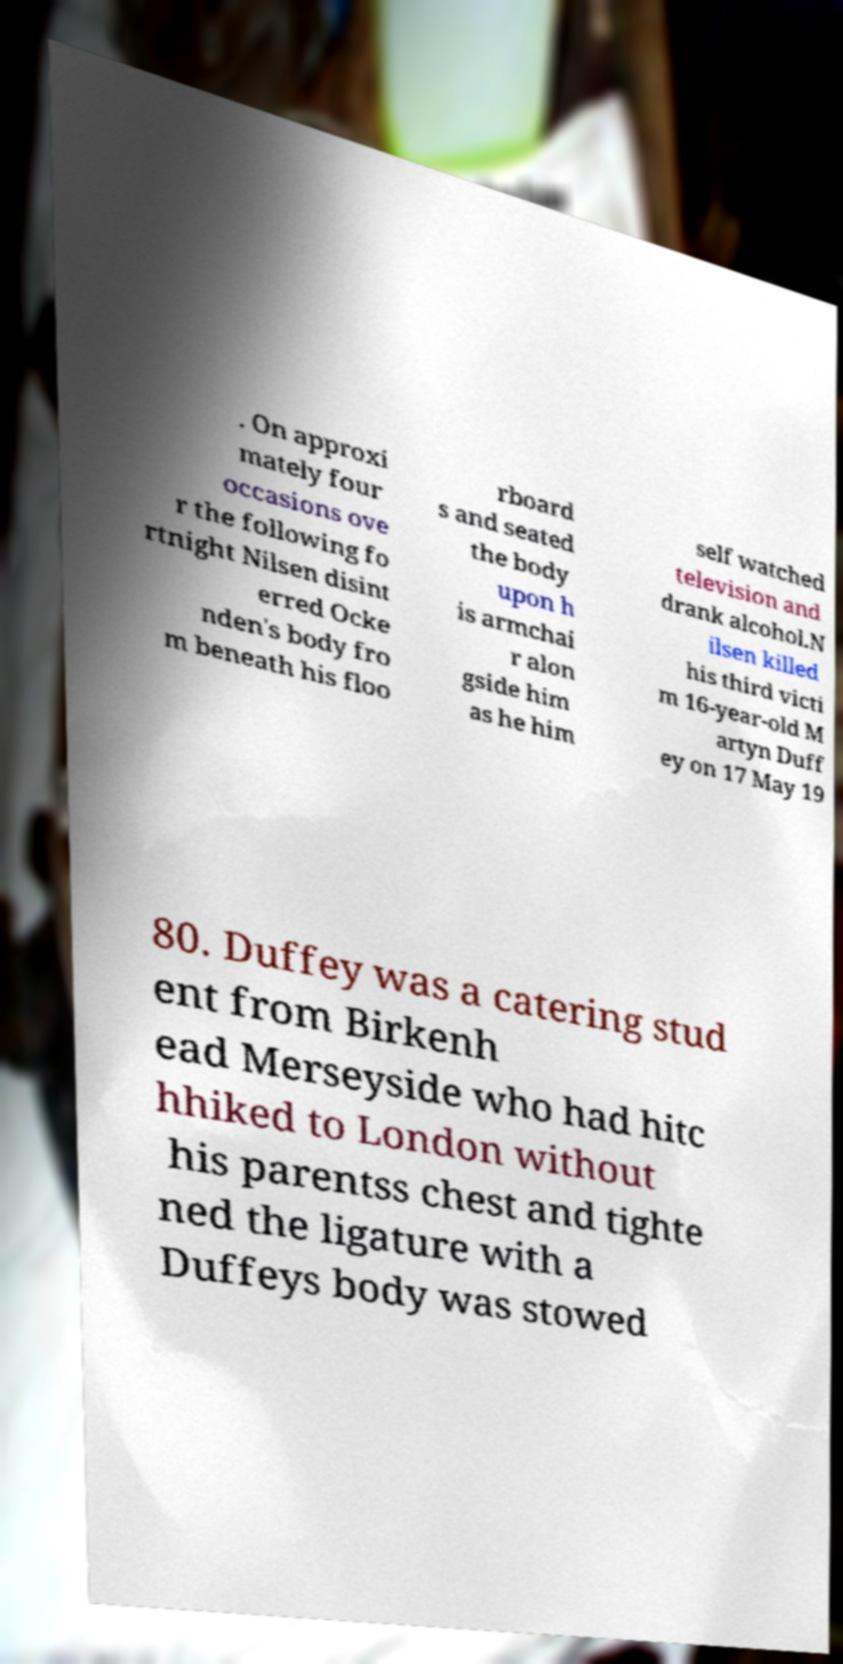I need the written content from this picture converted into text. Can you do that? . On approxi mately four occasions ove r the following fo rtnight Nilsen disint erred Ocke nden's body fro m beneath his floo rboard s and seated the body upon h is armchai r alon gside him as he him self watched television and drank alcohol.N ilsen killed his third victi m 16-year-old M artyn Duff ey on 17 May 19 80. Duffey was a catering stud ent from Birkenh ead Merseyside who had hitc hhiked to London without his parentss chest and tighte ned the ligature with a Duffeys body was stowed 